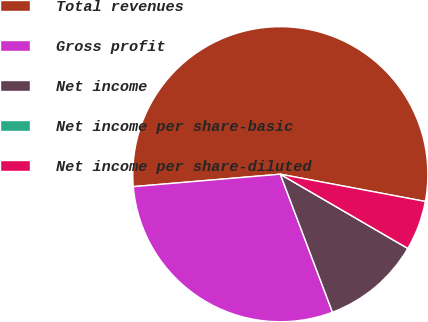Convert chart to OTSL. <chart><loc_0><loc_0><loc_500><loc_500><pie_chart><fcel>Total revenues<fcel>Gross profit<fcel>Net income<fcel>Net income per share-basic<fcel>Net income per share-diluted<nl><fcel>54.3%<fcel>29.41%<fcel>10.86%<fcel>0.0%<fcel>5.43%<nl></chart> 